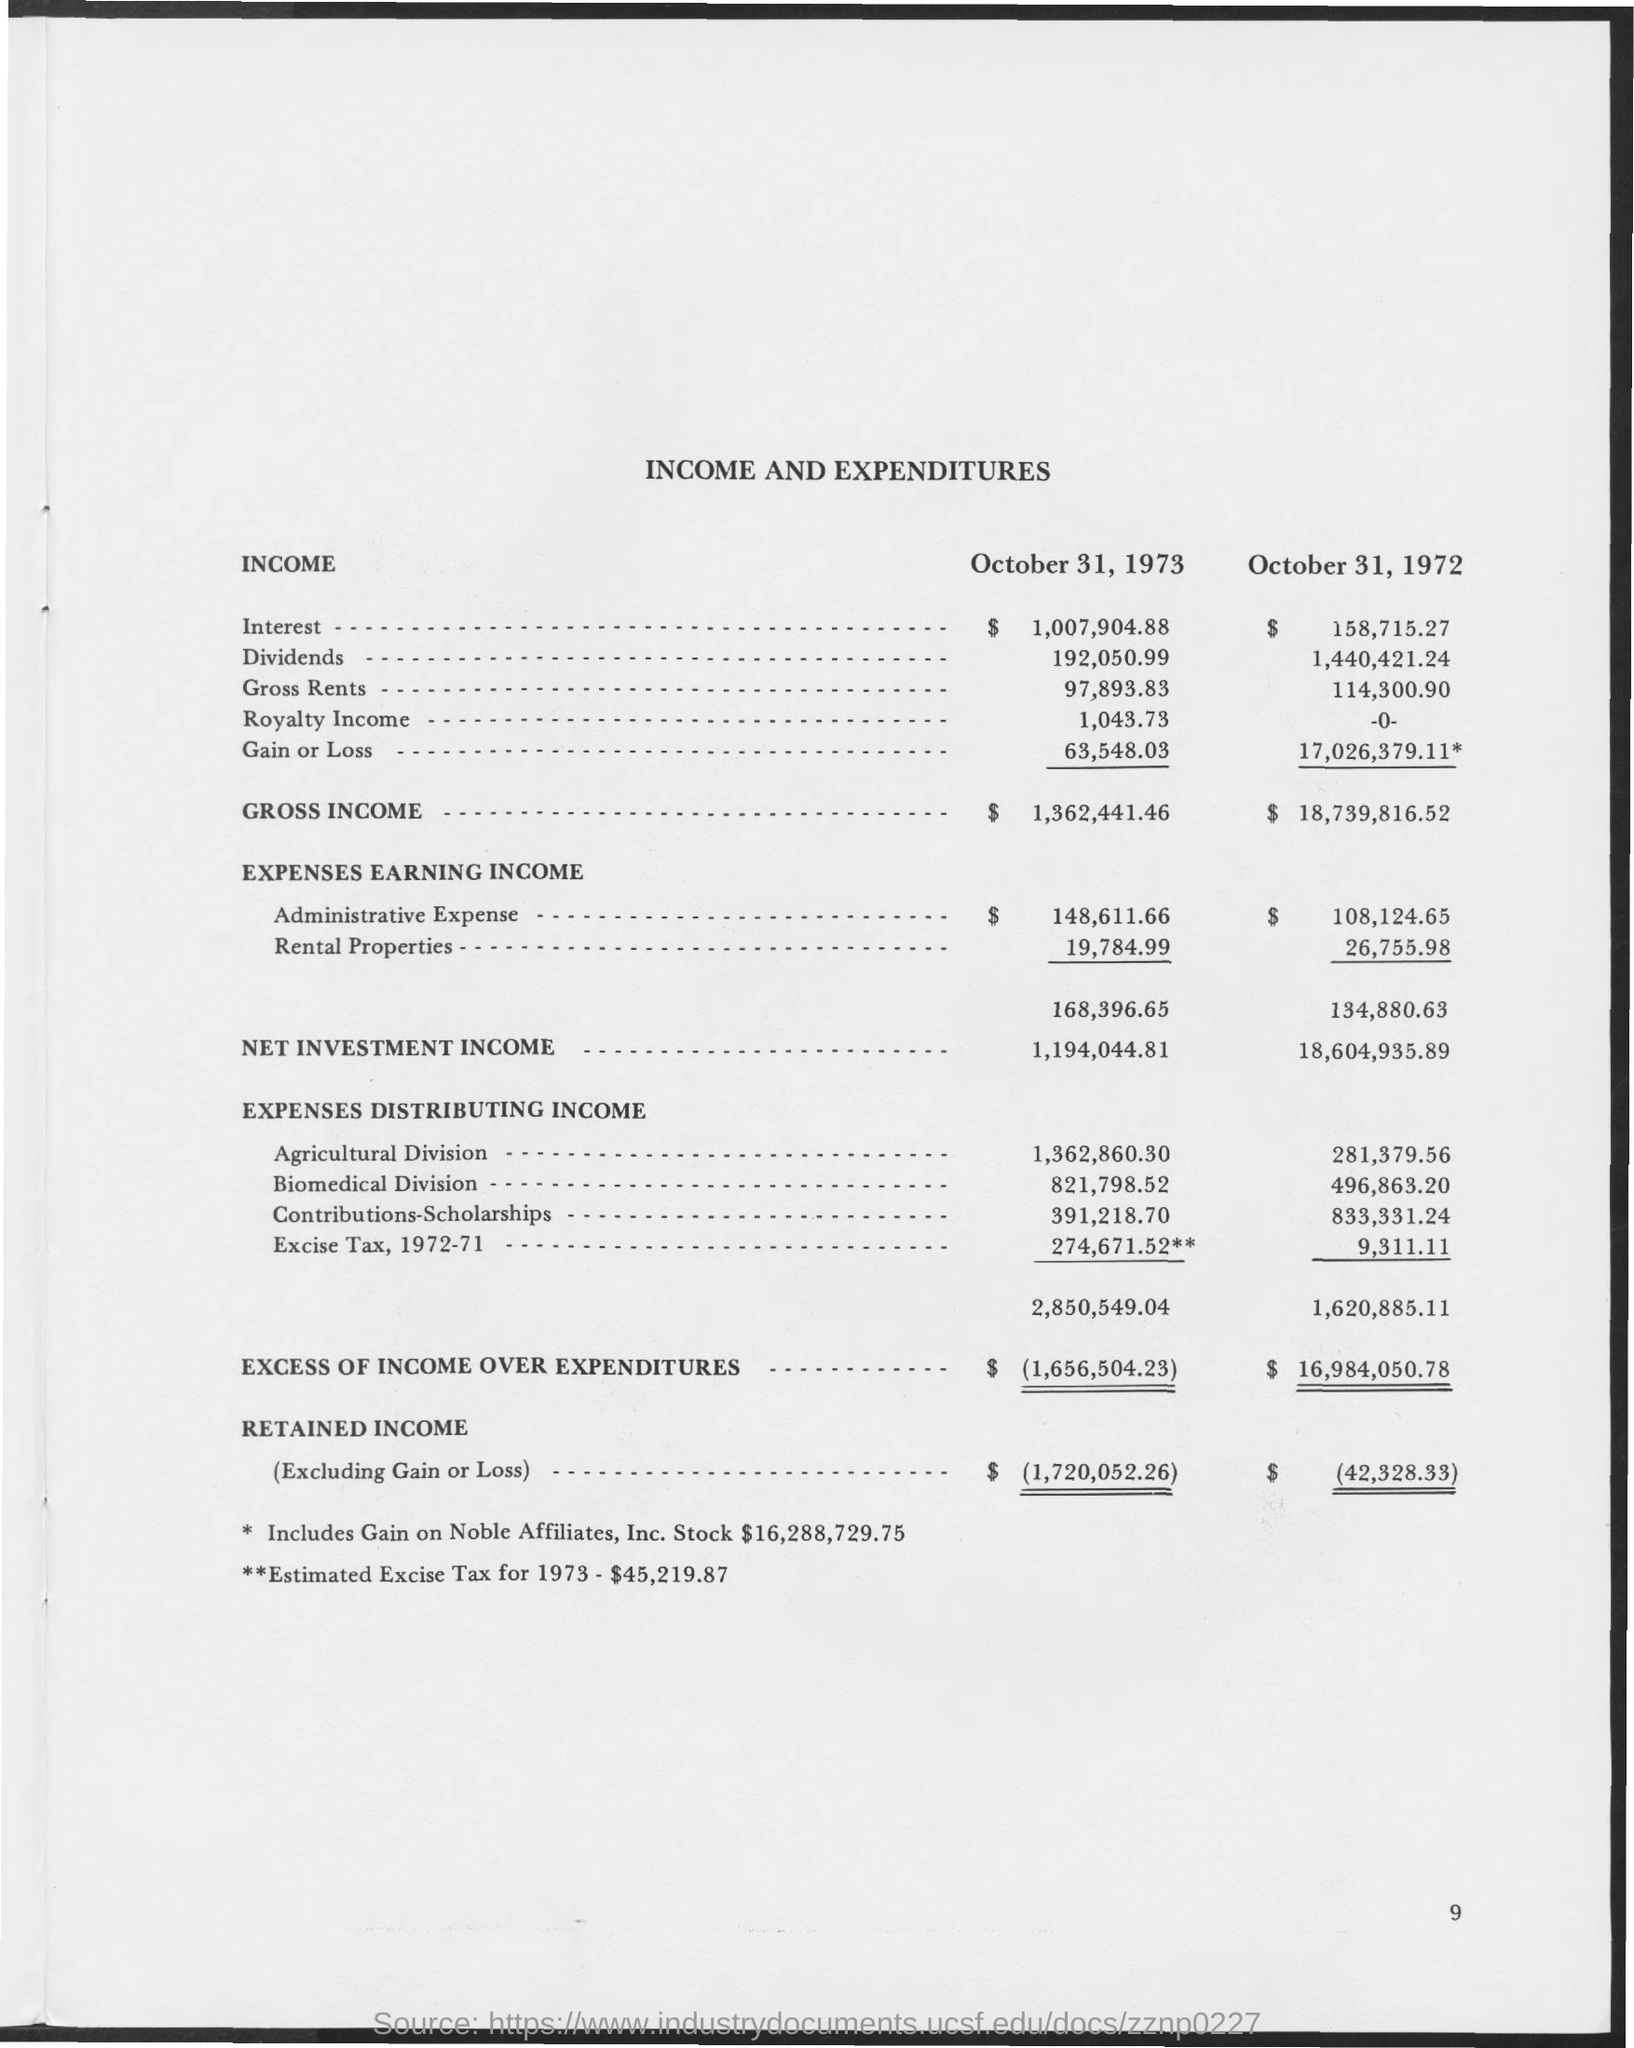What is the Gross Income as on October 31, 1973?
Your answer should be compact. $ 1,362,441.46. What is the Net Investment Income as on October 31, 1972?
Give a very brief answer. $ 18,604,935.89. What are the Expenses Earning Income for Rental properties as on October 31, 1973?
Ensure brevity in your answer.  $ 19,784.99. What are the Expenses Distributing Income for Biomedical Division as on October 31, 1973?
Your answer should be compact. 821,798.52. What is the Net Investment Income as on October 31, 1973?
Keep it short and to the point. 1,194,044.81. What is the Gross Income as on October 31, 1972?
Make the answer very short. $  18,739,816.52. What is the Excess of Income over Expenditures as on October 31, 1973?
Your answer should be very brief. $ (1,656,504.23). What is the Retained Income as on October 31, 1973?
Provide a succinct answer. $  (1,720,052.26). What is the Excess of Income over Expenditures as on October 31, 1972?
Offer a terse response. $ 16,984,050.78. 